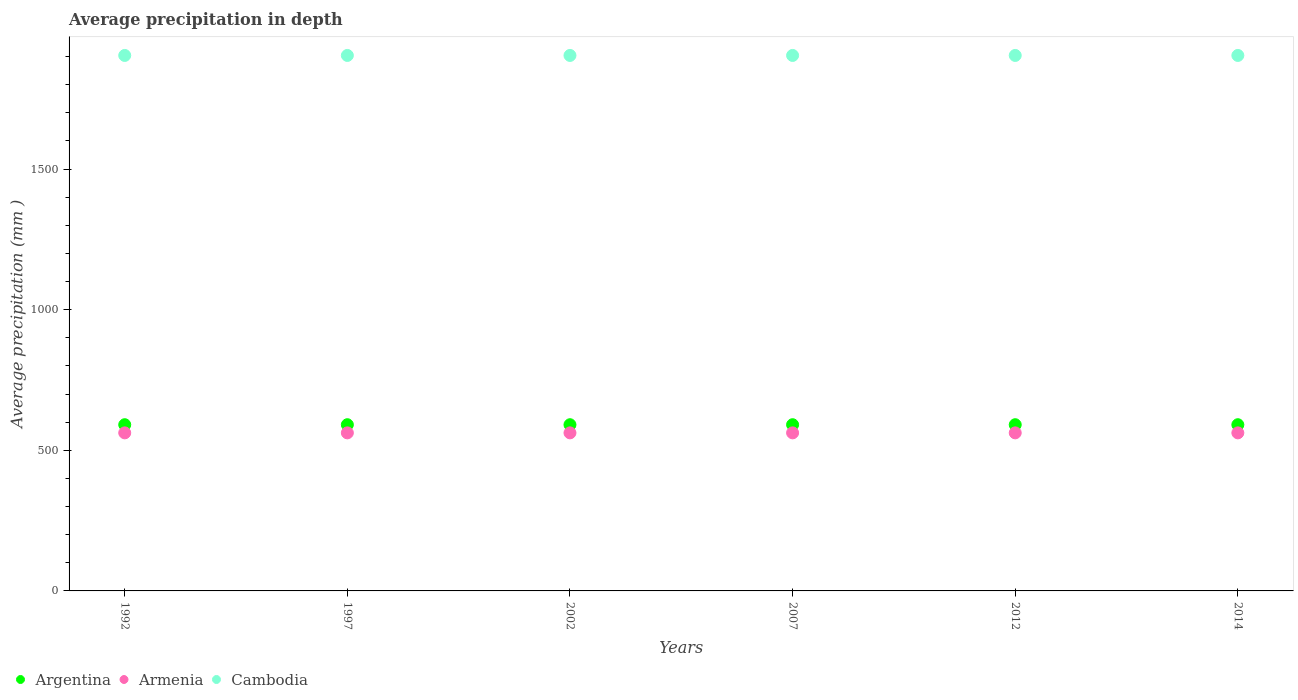How many different coloured dotlines are there?
Provide a succinct answer. 3. What is the average precipitation in Armenia in 1997?
Offer a terse response. 562. Across all years, what is the maximum average precipitation in Argentina?
Keep it short and to the point. 591. Across all years, what is the minimum average precipitation in Armenia?
Your answer should be compact. 562. In which year was the average precipitation in Argentina maximum?
Offer a terse response. 1992. In which year was the average precipitation in Armenia minimum?
Provide a succinct answer. 1992. What is the total average precipitation in Cambodia in the graph?
Keep it short and to the point. 1.14e+04. What is the difference between the average precipitation in Argentina in 1992 and that in 2007?
Make the answer very short. 0. What is the difference between the average precipitation in Armenia in 2014 and the average precipitation in Cambodia in 2012?
Offer a terse response. -1342. What is the average average precipitation in Argentina per year?
Provide a succinct answer. 591. What is the ratio of the average precipitation in Cambodia in 1997 to that in 2002?
Offer a very short reply. 1. Is the average precipitation in Armenia in 1992 less than that in 1997?
Offer a very short reply. No. What is the difference between the highest and the second highest average precipitation in Cambodia?
Keep it short and to the point. 0. In how many years, is the average precipitation in Armenia greater than the average average precipitation in Armenia taken over all years?
Keep it short and to the point. 0. Is it the case that in every year, the sum of the average precipitation in Cambodia and average precipitation in Argentina  is greater than the average precipitation in Armenia?
Provide a succinct answer. Yes. Is the average precipitation in Armenia strictly greater than the average precipitation in Argentina over the years?
Offer a terse response. No. Is the average precipitation in Armenia strictly less than the average precipitation in Argentina over the years?
Your answer should be compact. Yes. How many years are there in the graph?
Your answer should be compact. 6. What is the difference between two consecutive major ticks on the Y-axis?
Your response must be concise. 500. Are the values on the major ticks of Y-axis written in scientific E-notation?
Your answer should be very brief. No. Does the graph contain grids?
Your response must be concise. No. How are the legend labels stacked?
Offer a very short reply. Horizontal. What is the title of the graph?
Ensure brevity in your answer.  Average precipitation in depth. What is the label or title of the X-axis?
Offer a terse response. Years. What is the label or title of the Y-axis?
Provide a succinct answer. Average precipitation (mm ). What is the Average precipitation (mm ) of Argentina in 1992?
Make the answer very short. 591. What is the Average precipitation (mm ) in Armenia in 1992?
Offer a terse response. 562. What is the Average precipitation (mm ) in Cambodia in 1992?
Give a very brief answer. 1904. What is the Average precipitation (mm ) in Argentina in 1997?
Make the answer very short. 591. What is the Average precipitation (mm ) of Armenia in 1997?
Your response must be concise. 562. What is the Average precipitation (mm ) of Cambodia in 1997?
Provide a succinct answer. 1904. What is the Average precipitation (mm ) of Argentina in 2002?
Your response must be concise. 591. What is the Average precipitation (mm ) in Armenia in 2002?
Provide a short and direct response. 562. What is the Average precipitation (mm ) in Cambodia in 2002?
Make the answer very short. 1904. What is the Average precipitation (mm ) of Argentina in 2007?
Offer a terse response. 591. What is the Average precipitation (mm ) in Armenia in 2007?
Give a very brief answer. 562. What is the Average precipitation (mm ) of Cambodia in 2007?
Make the answer very short. 1904. What is the Average precipitation (mm ) in Argentina in 2012?
Keep it short and to the point. 591. What is the Average precipitation (mm ) in Armenia in 2012?
Offer a very short reply. 562. What is the Average precipitation (mm ) of Cambodia in 2012?
Offer a very short reply. 1904. What is the Average precipitation (mm ) in Argentina in 2014?
Provide a short and direct response. 591. What is the Average precipitation (mm ) in Armenia in 2014?
Keep it short and to the point. 562. What is the Average precipitation (mm ) in Cambodia in 2014?
Keep it short and to the point. 1904. Across all years, what is the maximum Average precipitation (mm ) of Argentina?
Your answer should be very brief. 591. Across all years, what is the maximum Average precipitation (mm ) in Armenia?
Offer a very short reply. 562. Across all years, what is the maximum Average precipitation (mm ) of Cambodia?
Provide a short and direct response. 1904. Across all years, what is the minimum Average precipitation (mm ) in Argentina?
Offer a terse response. 591. Across all years, what is the minimum Average precipitation (mm ) of Armenia?
Keep it short and to the point. 562. Across all years, what is the minimum Average precipitation (mm ) in Cambodia?
Offer a terse response. 1904. What is the total Average precipitation (mm ) of Argentina in the graph?
Ensure brevity in your answer.  3546. What is the total Average precipitation (mm ) in Armenia in the graph?
Provide a succinct answer. 3372. What is the total Average precipitation (mm ) of Cambodia in the graph?
Your answer should be very brief. 1.14e+04. What is the difference between the Average precipitation (mm ) of Argentina in 1992 and that in 1997?
Provide a short and direct response. 0. What is the difference between the Average precipitation (mm ) of Cambodia in 1992 and that in 1997?
Keep it short and to the point. 0. What is the difference between the Average precipitation (mm ) in Argentina in 1992 and that in 2002?
Offer a very short reply. 0. What is the difference between the Average precipitation (mm ) of Argentina in 1992 and that in 2007?
Your answer should be very brief. 0. What is the difference between the Average precipitation (mm ) of Armenia in 1992 and that in 2007?
Make the answer very short. 0. What is the difference between the Average precipitation (mm ) of Argentina in 1992 and that in 2012?
Your answer should be compact. 0. What is the difference between the Average precipitation (mm ) of Armenia in 1992 and that in 2012?
Give a very brief answer. 0. What is the difference between the Average precipitation (mm ) of Cambodia in 1992 and that in 2012?
Your answer should be compact. 0. What is the difference between the Average precipitation (mm ) of Argentina in 1992 and that in 2014?
Make the answer very short. 0. What is the difference between the Average precipitation (mm ) in Armenia in 1997 and that in 2002?
Your response must be concise. 0. What is the difference between the Average precipitation (mm ) of Argentina in 1997 and that in 2014?
Ensure brevity in your answer.  0. What is the difference between the Average precipitation (mm ) in Argentina in 2002 and that in 2012?
Give a very brief answer. 0. What is the difference between the Average precipitation (mm ) of Argentina in 2002 and that in 2014?
Keep it short and to the point. 0. What is the difference between the Average precipitation (mm ) in Cambodia in 2002 and that in 2014?
Give a very brief answer. 0. What is the difference between the Average precipitation (mm ) in Argentina in 2007 and that in 2014?
Ensure brevity in your answer.  0. What is the difference between the Average precipitation (mm ) of Cambodia in 2012 and that in 2014?
Your answer should be compact. 0. What is the difference between the Average precipitation (mm ) of Argentina in 1992 and the Average precipitation (mm ) of Cambodia in 1997?
Offer a terse response. -1313. What is the difference between the Average precipitation (mm ) of Armenia in 1992 and the Average precipitation (mm ) of Cambodia in 1997?
Your response must be concise. -1342. What is the difference between the Average precipitation (mm ) of Argentina in 1992 and the Average precipitation (mm ) of Armenia in 2002?
Your response must be concise. 29. What is the difference between the Average precipitation (mm ) of Argentina in 1992 and the Average precipitation (mm ) of Cambodia in 2002?
Provide a succinct answer. -1313. What is the difference between the Average precipitation (mm ) of Armenia in 1992 and the Average precipitation (mm ) of Cambodia in 2002?
Ensure brevity in your answer.  -1342. What is the difference between the Average precipitation (mm ) of Argentina in 1992 and the Average precipitation (mm ) of Cambodia in 2007?
Give a very brief answer. -1313. What is the difference between the Average precipitation (mm ) in Armenia in 1992 and the Average precipitation (mm ) in Cambodia in 2007?
Provide a short and direct response. -1342. What is the difference between the Average precipitation (mm ) in Argentina in 1992 and the Average precipitation (mm ) in Armenia in 2012?
Ensure brevity in your answer.  29. What is the difference between the Average precipitation (mm ) of Argentina in 1992 and the Average precipitation (mm ) of Cambodia in 2012?
Provide a short and direct response. -1313. What is the difference between the Average precipitation (mm ) in Armenia in 1992 and the Average precipitation (mm ) in Cambodia in 2012?
Keep it short and to the point. -1342. What is the difference between the Average precipitation (mm ) in Argentina in 1992 and the Average precipitation (mm ) in Cambodia in 2014?
Your response must be concise. -1313. What is the difference between the Average precipitation (mm ) of Armenia in 1992 and the Average precipitation (mm ) of Cambodia in 2014?
Provide a short and direct response. -1342. What is the difference between the Average precipitation (mm ) in Argentina in 1997 and the Average precipitation (mm ) in Cambodia in 2002?
Make the answer very short. -1313. What is the difference between the Average precipitation (mm ) in Armenia in 1997 and the Average precipitation (mm ) in Cambodia in 2002?
Your answer should be very brief. -1342. What is the difference between the Average precipitation (mm ) in Argentina in 1997 and the Average precipitation (mm ) in Cambodia in 2007?
Your response must be concise. -1313. What is the difference between the Average precipitation (mm ) of Armenia in 1997 and the Average precipitation (mm ) of Cambodia in 2007?
Keep it short and to the point. -1342. What is the difference between the Average precipitation (mm ) in Argentina in 1997 and the Average precipitation (mm ) in Armenia in 2012?
Ensure brevity in your answer.  29. What is the difference between the Average precipitation (mm ) in Argentina in 1997 and the Average precipitation (mm ) in Cambodia in 2012?
Your response must be concise. -1313. What is the difference between the Average precipitation (mm ) of Armenia in 1997 and the Average precipitation (mm ) of Cambodia in 2012?
Give a very brief answer. -1342. What is the difference between the Average precipitation (mm ) of Argentina in 1997 and the Average precipitation (mm ) of Cambodia in 2014?
Provide a short and direct response. -1313. What is the difference between the Average precipitation (mm ) of Armenia in 1997 and the Average precipitation (mm ) of Cambodia in 2014?
Keep it short and to the point. -1342. What is the difference between the Average precipitation (mm ) of Argentina in 2002 and the Average precipitation (mm ) of Cambodia in 2007?
Offer a very short reply. -1313. What is the difference between the Average precipitation (mm ) in Armenia in 2002 and the Average precipitation (mm ) in Cambodia in 2007?
Provide a succinct answer. -1342. What is the difference between the Average precipitation (mm ) in Argentina in 2002 and the Average precipitation (mm ) in Armenia in 2012?
Offer a terse response. 29. What is the difference between the Average precipitation (mm ) in Argentina in 2002 and the Average precipitation (mm ) in Cambodia in 2012?
Your response must be concise. -1313. What is the difference between the Average precipitation (mm ) in Armenia in 2002 and the Average precipitation (mm ) in Cambodia in 2012?
Your answer should be compact. -1342. What is the difference between the Average precipitation (mm ) in Argentina in 2002 and the Average precipitation (mm ) in Cambodia in 2014?
Provide a succinct answer. -1313. What is the difference between the Average precipitation (mm ) in Armenia in 2002 and the Average precipitation (mm ) in Cambodia in 2014?
Offer a very short reply. -1342. What is the difference between the Average precipitation (mm ) in Argentina in 2007 and the Average precipitation (mm ) in Armenia in 2012?
Your answer should be very brief. 29. What is the difference between the Average precipitation (mm ) in Argentina in 2007 and the Average precipitation (mm ) in Cambodia in 2012?
Keep it short and to the point. -1313. What is the difference between the Average precipitation (mm ) in Armenia in 2007 and the Average precipitation (mm ) in Cambodia in 2012?
Your answer should be compact. -1342. What is the difference between the Average precipitation (mm ) in Argentina in 2007 and the Average precipitation (mm ) in Armenia in 2014?
Offer a very short reply. 29. What is the difference between the Average precipitation (mm ) in Argentina in 2007 and the Average precipitation (mm ) in Cambodia in 2014?
Ensure brevity in your answer.  -1313. What is the difference between the Average precipitation (mm ) in Armenia in 2007 and the Average precipitation (mm ) in Cambodia in 2014?
Offer a terse response. -1342. What is the difference between the Average precipitation (mm ) of Argentina in 2012 and the Average precipitation (mm ) of Cambodia in 2014?
Offer a very short reply. -1313. What is the difference between the Average precipitation (mm ) in Armenia in 2012 and the Average precipitation (mm ) in Cambodia in 2014?
Your answer should be compact. -1342. What is the average Average precipitation (mm ) in Argentina per year?
Keep it short and to the point. 591. What is the average Average precipitation (mm ) in Armenia per year?
Provide a short and direct response. 562. What is the average Average precipitation (mm ) of Cambodia per year?
Offer a terse response. 1904. In the year 1992, what is the difference between the Average precipitation (mm ) of Argentina and Average precipitation (mm ) of Armenia?
Offer a very short reply. 29. In the year 1992, what is the difference between the Average precipitation (mm ) of Argentina and Average precipitation (mm ) of Cambodia?
Keep it short and to the point. -1313. In the year 1992, what is the difference between the Average precipitation (mm ) of Armenia and Average precipitation (mm ) of Cambodia?
Your answer should be very brief. -1342. In the year 1997, what is the difference between the Average precipitation (mm ) in Argentina and Average precipitation (mm ) in Armenia?
Ensure brevity in your answer.  29. In the year 1997, what is the difference between the Average precipitation (mm ) in Argentina and Average precipitation (mm ) in Cambodia?
Ensure brevity in your answer.  -1313. In the year 1997, what is the difference between the Average precipitation (mm ) of Armenia and Average precipitation (mm ) of Cambodia?
Offer a very short reply. -1342. In the year 2002, what is the difference between the Average precipitation (mm ) in Argentina and Average precipitation (mm ) in Cambodia?
Your answer should be very brief. -1313. In the year 2002, what is the difference between the Average precipitation (mm ) in Armenia and Average precipitation (mm ) in Cambodia?
Provide a succinct answer. -1342. In the year 2007, what is the difference between the Average precipitation (mm ) of Argentina and Average precipitation (mm ) of Cambodia?
Provide a short and direct response. -1313. In the year 2007, what is the difference between the Average precipitation (mm ) in Armenia and Average precipitation (mm ) in Cambodia?
Offer a very short reply. -1342. In the year 2012, what is the difference between the Average precipitation (mm ) of Argentina and Average precipitation (mm ) of Armenia?
Provide a succinct answer. 29. In the year 2012, what is the difference between the Average precipitation (mm ) in Argentina and Average precipitation (mm ) in Cambodia?
Make the answer very short. -1313. In the year 2012, what is the difference between the Average precipitation (mm ) of Armenia and Average precipitation (mm ) of Cambodia?
Keep it short and to the point. -1342. In the year 2014, what is the difference between the Average precipitation (mm ) of Argentina and Average precipitation (mm ) of Armenia?
Make the answer very short. 29. In the year 2014, what is the difference between the Average precipitation (mm ) in Argentina and Average precipitation (mm ) in Cambodia?
Ensure brevity in your answer.  -1313. In the year 2014, what is the difference between the Average precipitation (mm ) of Armenia and Average precipitation (mm ) of Cambodia?
Make the answer very short. -1342. What is the ratio of the Average precipitation (mm ) of Argentina in 1992 to that in 2002?
Offer a terse response. 1. What is the ratio of the Average precipitation (mm ) in Cambodia in 1992 to that in 2002?
Your response must be concise. 1. What is the ratio of the Average precipitation (mm ) of Argentina in 1992 to that in 2007?
Ensure brevity in your answer.  1. What is the ratio of the Average precipitation (mm ) in Cambodia in 1992 to that in 2007?
Your response must be concise. 1. What is the ratio of the Average precipitation (mm ) in Argentina in 1992 to that in 2012?
Provide a succinct answer. 1. What is the ratio of the Average precipitation (mm ) in Armenia in 1992 to that in 2012?
Your response must be concise. 1. What is the ratio of the Average precipitation (mm ) of Armenia in 1992 to that in 2014?
Keep it short and to the point. 1. What is the ratio of the Average precipitation (mm ) of Cambodia in 1992 to that in 2014?
Offer a very short reply. 1. What is the ratio of the Average precipitation (mm ) of Argentina in 1997 to that in 2007?
Offer a terse response. 1. What is the ratio of the Average precipitation (mm ) of Armenia in 1997 to that in 2007?
Make the answer very short. 1. What is the ratio of the Average precipitation (mm ) in Cambodia in 1997 to that in 2007?
Your answer should be compact. 1. What is the ratio of the Average precipitation (mm ) in Argentina in 1997 to that in 2012?
Offer a very short reply. 1. What is the ratio of the Average precipitation (mm ) of Armenia in 1997 to that in 2014?
Your answer should be compact. 1. What is the ratio of the Average precipitation (mm ) of Argentina in 2002 to that in 2007?
Your response must be concise. 1. What is the ratio of the Average precipitation (mm ) in Argentina in 2002 to that in 2012?
Offer a terse response. 1. What is the ratio of the Average precipitation (mm ) in Argentina in 2002 to that in 2014?
Provide a succinct answer. 1. What is the ratio of the Average precipitation (mm ) of Cambodia in 2002 to that in 2014?
Keep it short and to the point. 1. What is the ratio of the Average precipitation (mm ) in Armenia in 2007 to that in 2012?
Offer a very short reply. 1. What is the ratio of the Average precipitation (mm ) in Argentina in 2007 to that in 2014?
Offer a terse response. 1. What is the difference between the highest and the second highest Average precipitation (mm ) in Cambodia?
Your answer should be compact. 0. What is the difference between the highest and the lowest Average precipitation (mm ) in Cambodia?
Ensure brevity in your answer.  0. 